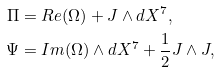<formula> <loc_0><loc_0><loc_500><loc_500>\Pi & = R e ( \Omega ) + J \wedge d X ^ { 7 } , \\ \Psi & = I m ( \Omega ) \wedge d X ^ { 7 } + \frac { 1 } { 2 } J \wedge J ,</formula> 